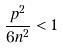Convert formula to latex. <formula><loc_0><loc_0><loc_500><loc_500>\frac { p ^ { 2 } } { 6 n ^ { 2 } } < 1</formula> 